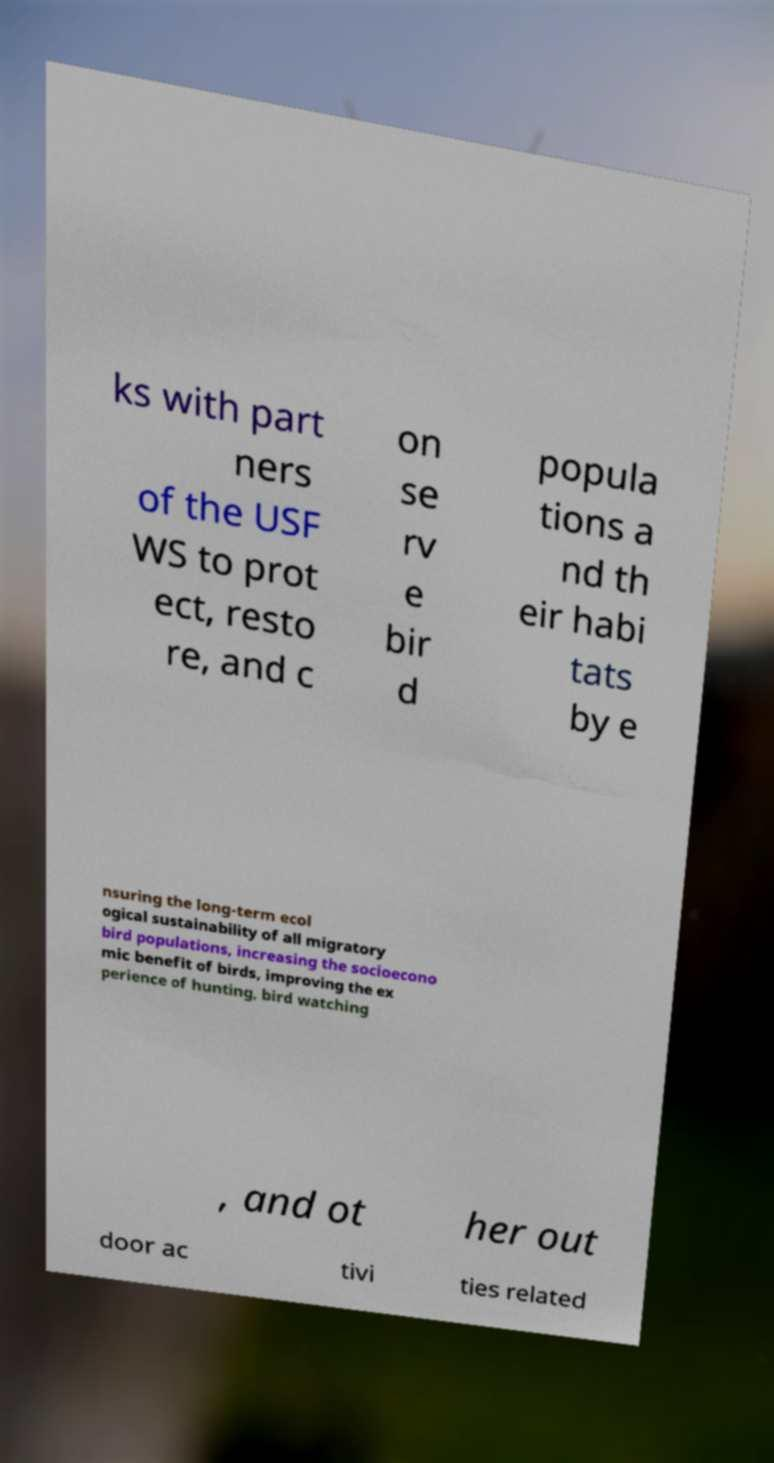Please read and relay the text visible in this image. What does it say? ks with part ners of the USF WS to prot ect, resto re, and c on se rv e bir d popula tions a nd th eir habi tats by e nsuring the long-term ecol ogical sustainability of all migratory bird populations, increasing the socioecono mic benefit of birds, improving the ex perience of hunting, bird watching , and ot her out door ac tivi ties related 